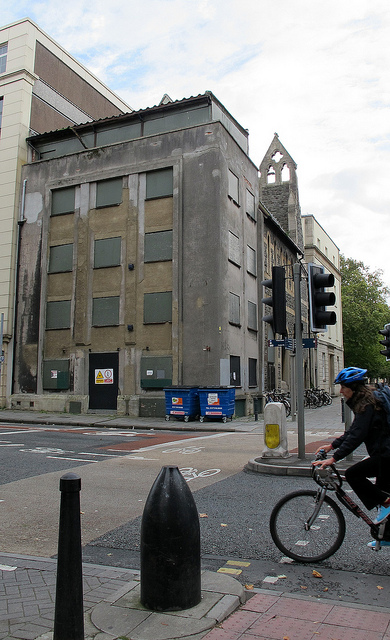<image>What model bike is that? I don't know the exact model of the bike. It could be Schwinn, racing, mountain bike, or bmx. What model bike is that? I don't know what model bike it is. It could be Schwinn, racing, mountain bike, BMX, Ten speed or unknown. 